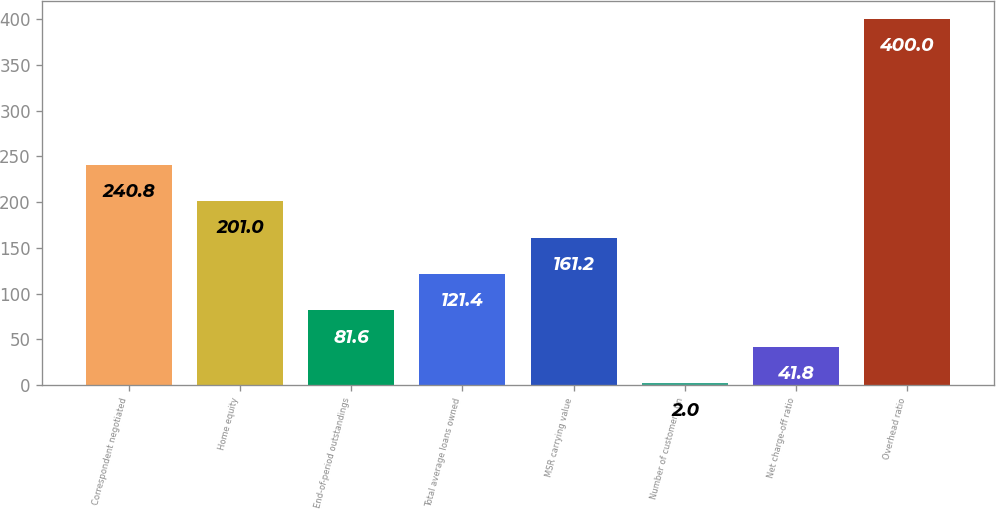Convert chart to OTSL. <chart><loc_0><loc_0><loc_500><loc_500><bar_chart><fcel>Correspondent negotiated<fcel>Home equity<fcel>End-of-period outstandings<fcel>Total average loans owned<fcel>MSR carrying value<fcel>Number of customers (in<fcel>Net charge-off ratio<fcel>Overhead ratio<nl><fcel>240.8<fcel>201<fcel>81.6<fcel>121.4<fcel>161.2<fcel>2<fcel>41.8<fcel>400<nl></chart> 